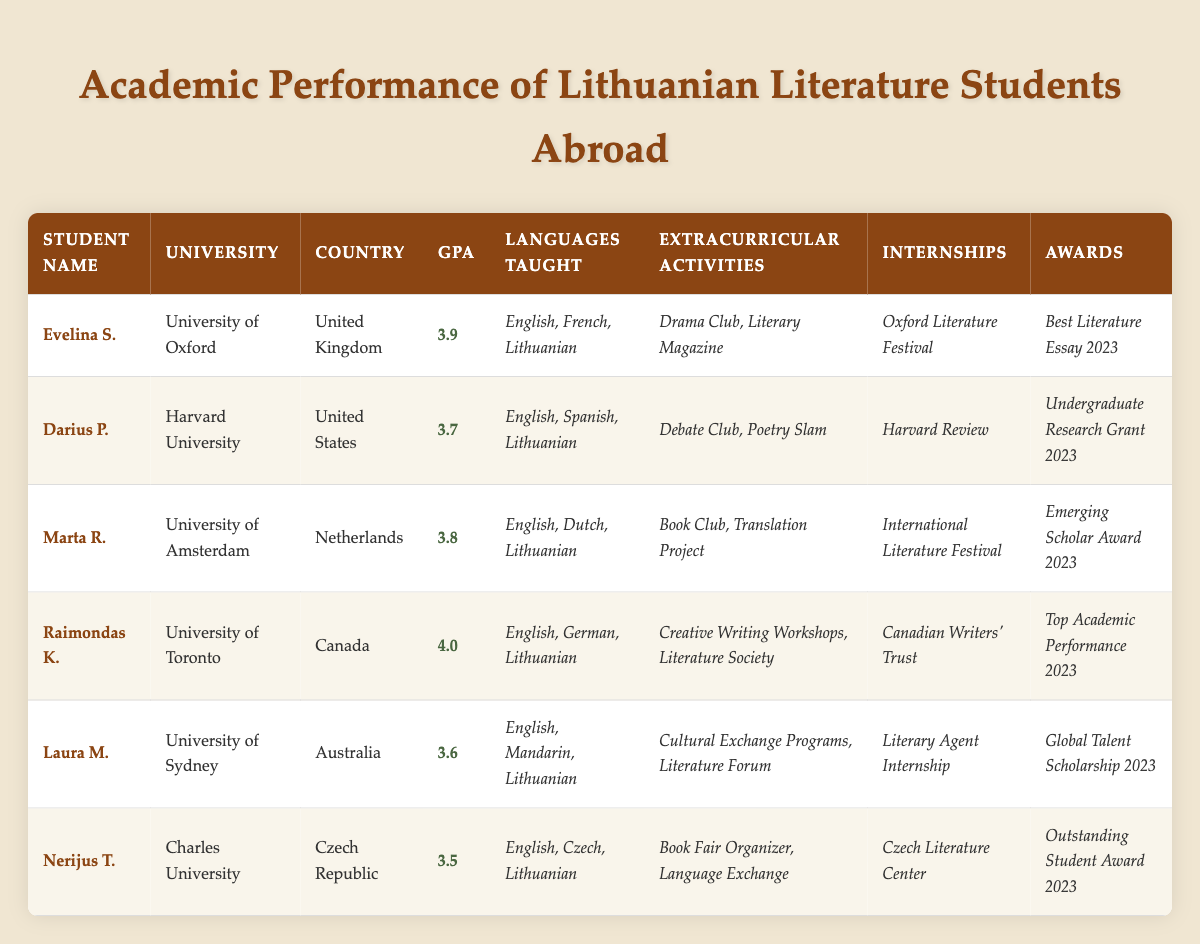What is the highest GPA among the students listed? Looking through the GPA values in the table, the highest value is 4.0, which belongs to Raimondas K.
Answer: 4.0 Which student is studying at Harvard University? The table directly specifies that Darius P. is the student attending Harvard University.
Answer: Darius P How many students have a GPA above 3.7? By reviewing the GPA values: Evelina S. (3.9), Marta R. (3.8), and Raimondas K. (4.0) have GPAs above 3.7, totaling 3 students.
Answer: 3 What languages are taught by Laura M.? The table indicates that Laura M. teaches English, Mandarin, and Lithuanian.
Answer: English, Mandarin, Lithuanian Did any student participate in an internship at the Canadian Writers’ Trust? The table shows that Raimondas K. interned at the Canadian Writers' Trust, confirming that at least one student participated.
Answer: Yes What is the average GPA of students studying at universities in the United States? The GPAs for students at US universities (Darius P. - 3.7) are summed up (3.7) and averaged, since there is only one student, the average is 3.7.
Answer: 3.7 Which awards did Marta R. receive? From the table, Marta R. received the Emerging Scholar Award 2023.
Answer: Emerging Scholar Award 2023 Is there a student who has received multiple awards listed in the table? No student is noted to have more than one award in the table, indicating that each student received a unique award.
Answer: No What are the extracurricular activities of students from the University of Oxford and the University of Sydney combined? Evelina S. (University of Oxford) is involved in the Drama Club and Literary Magazine, while Laura M. (University of Sydney) participates in Cultural Exchange Programs and Literature Forum. Combined, the activities are Drama Club, Literary Magazine, Cultural Exchange Programs, and Literature Forum.
Answer: Drama Club, Literary Magazine, Cultural Exchange Programs, Literature Forum Which student teaches both English and Czech? Looking at the languages taught, only Nerijus T. teaches English and Czech.
Answer: Nerijus T 